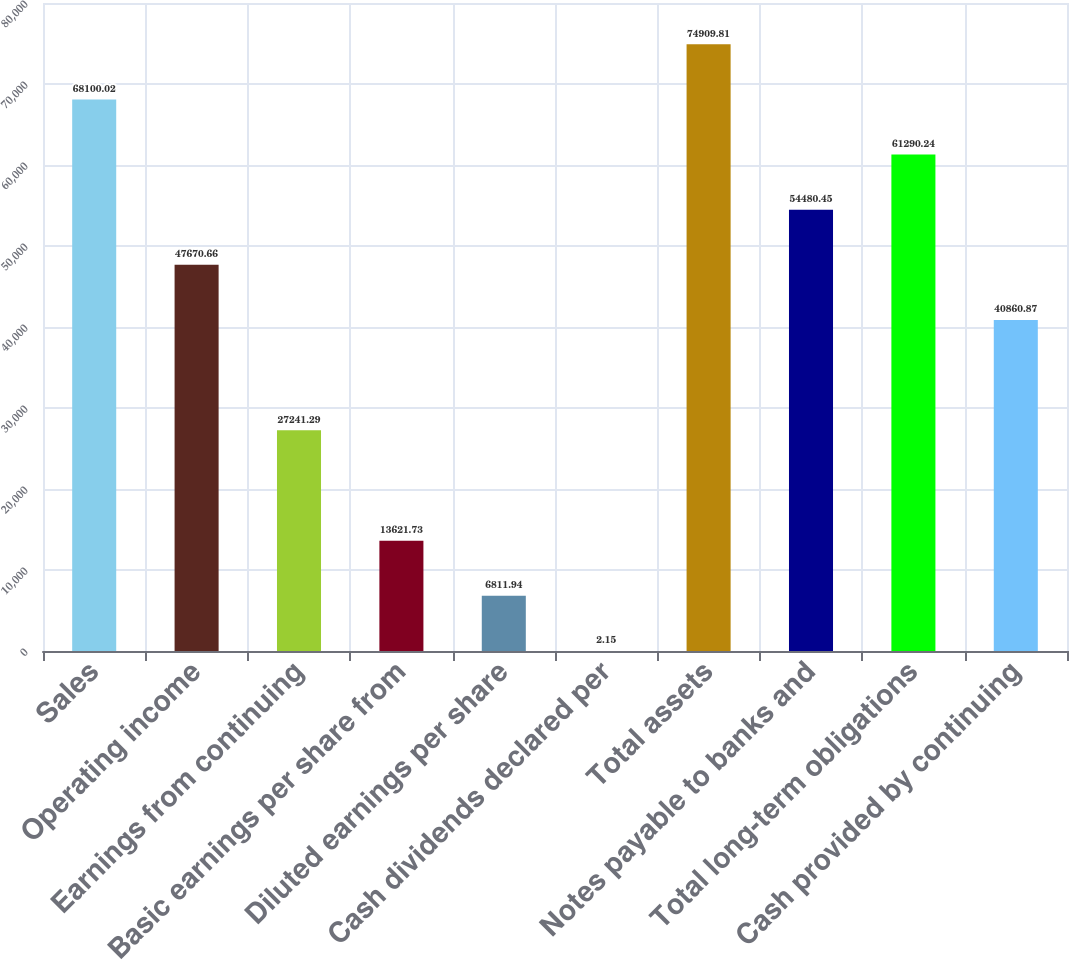Convert chart. <chart><loc_0><loc_0><loc_500><loc_500><bar_chart><fcel>Sales<fcel>Operating income<fcel>Earnings from continuing<fcel>Basic earnings per share from<fcel>Diluted earnings per share<fcel>Cash dividends declared per<fcel>Total assets<fcel>Notes payable to banks and<fcel>Total long-term obligations<fcel>Cash provided by continuing<nl><fcel>68100<fcel>47670.7<fcel>27241.3<fcel>13621.7<fcel>6811.94<fcel>2.15<fcel>74909.8<fcel>54480.4<fcel>61290.2<fcel>40860.9<nl></chart> 